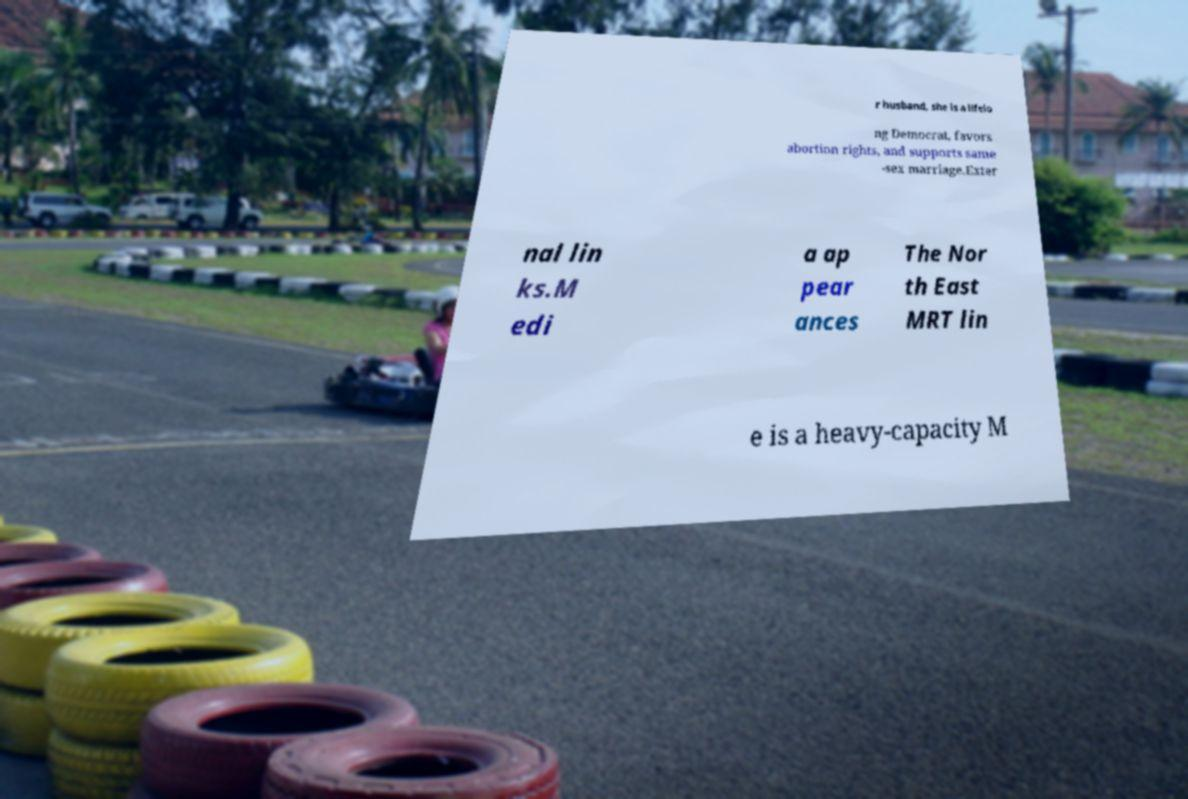Could you extract and type out the text from this image? r husband, she is a lifelo ng Democrat, favors abortion rights, and supports same -sex marriage.Exter nal lin ks.M edi a ap pear ances The Nor th East MRT lin e is a heavy-capacity M 